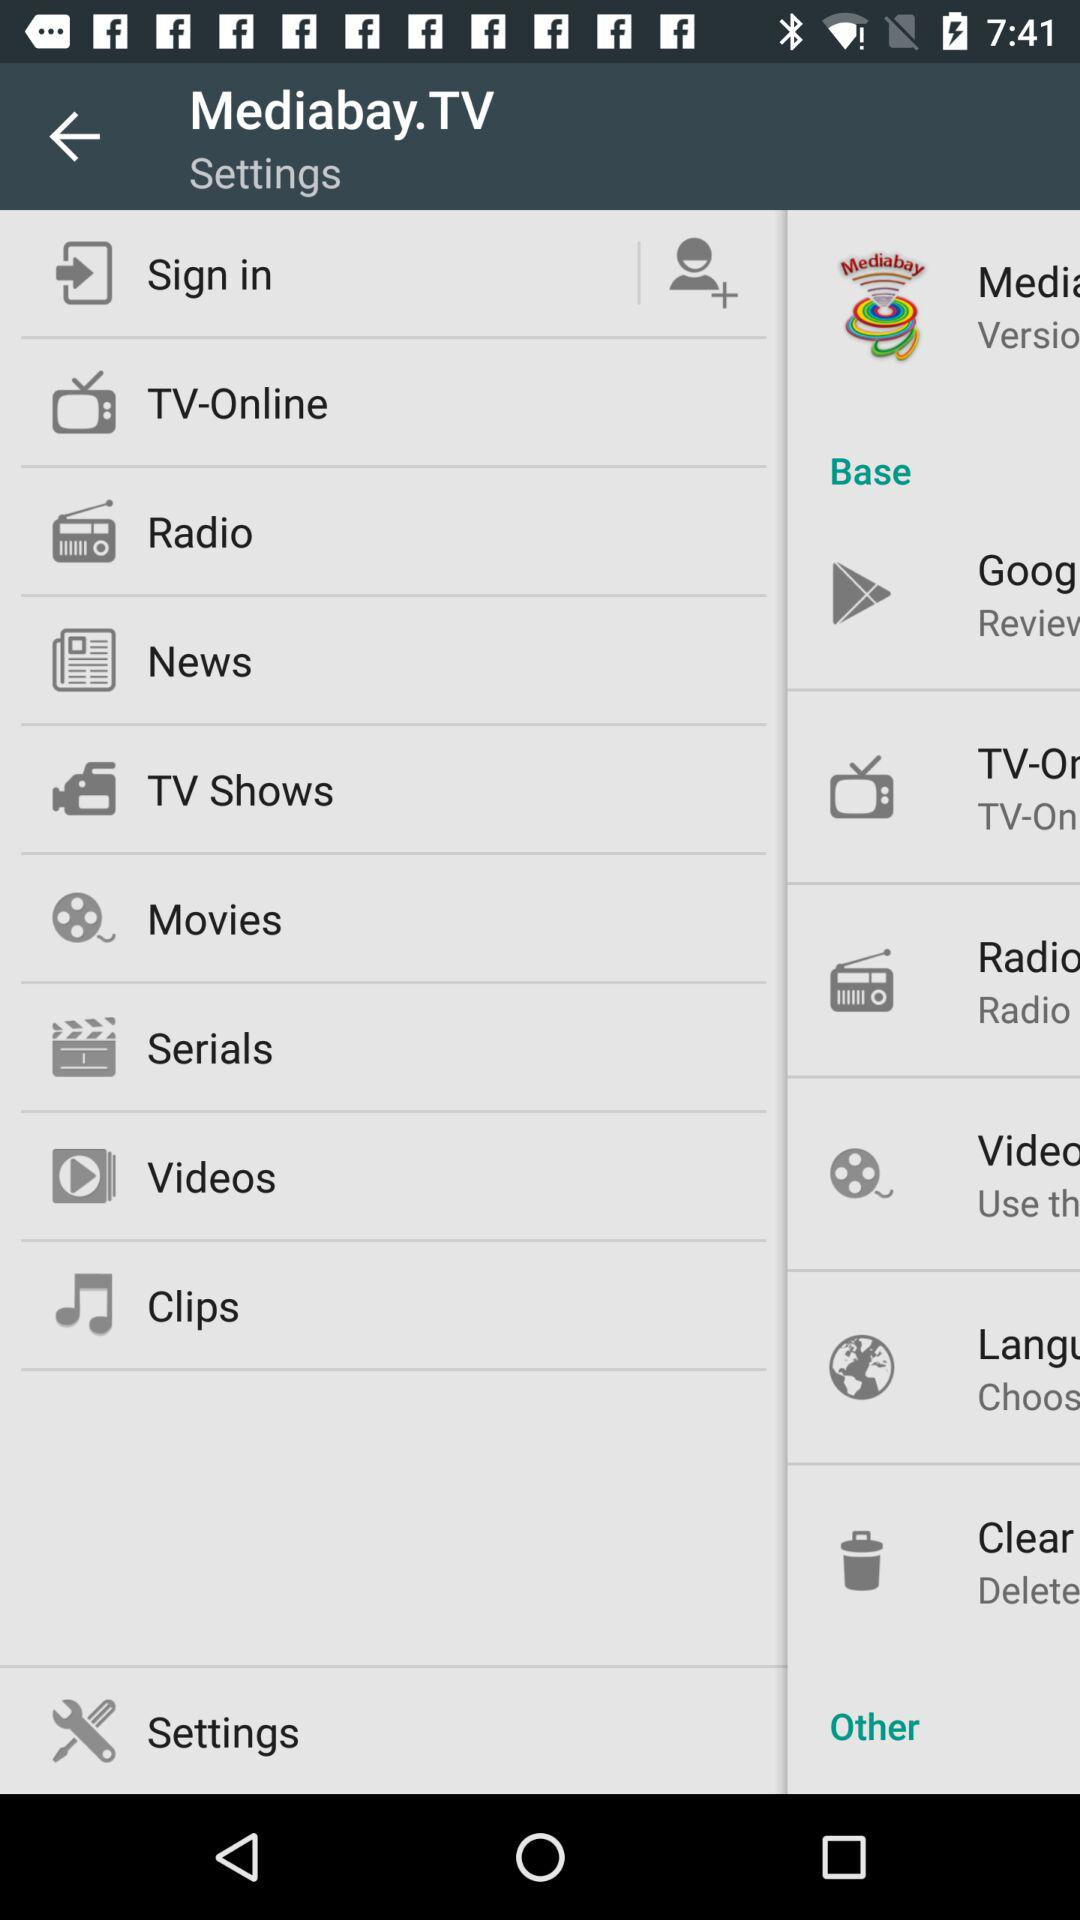What is the application name? The application name is "Mediabay.TV". 